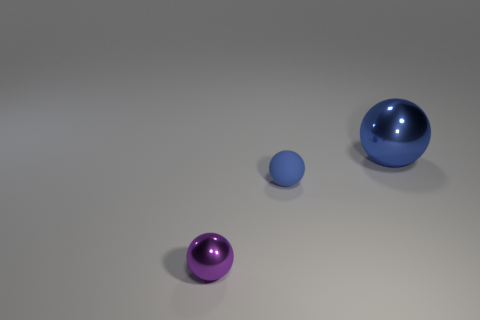Can you describe the lighting and shadows present in the scene? The lighting in the scene is soft and diffuse, creating gentle shadows that spread out from the objects on the ground. The subtle shading suggests a single light source above the scene, and the softness indicates that the light is not overly harsh or direct. The scene's calm ambiance is accentuated by the light's direction, intensity, and the way the objects subtly reflect it. 